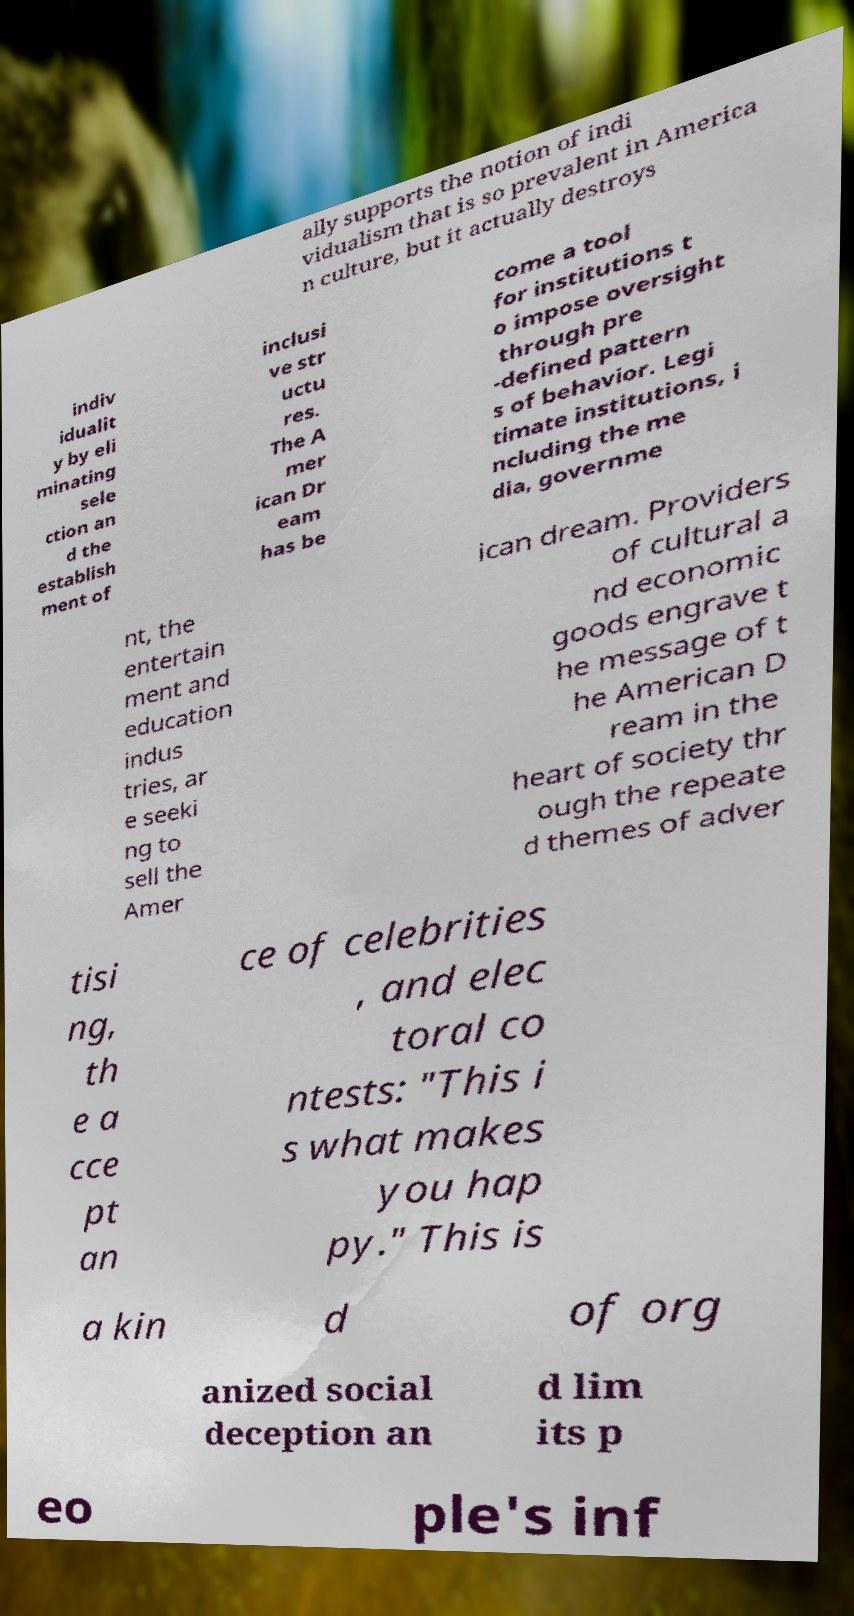Could you assist in decoding the text presented in this image and type it out clearly? ally supports the notion of indi vidualism that is so prevalent in America n culture, but it actually destroys indiv idualit y by eli minating sele ction an d the establish ment of inclusi ve str uctu res. The A mer ican Dr eam has be come a tool for institutions t o impose oversight through pre -defined pattern s of behavior. Legi timate institutions, i ncluding the me dia, governme nt, the entertain ment and education indus tries, ar e seeki ng to sell the Amer ican dream. Providers of cultural a nd economic goods engrave t he message of t he American D ream in the heart of society thr ough the repeate d themes of adver tisi ng, th e a cce pt an ce of celebrities , and elec toral co ntests: "This i s what makes you hap py." This is a kin d of org anized social deception an d lim its p eo ple's inf 